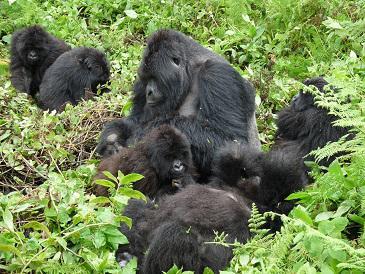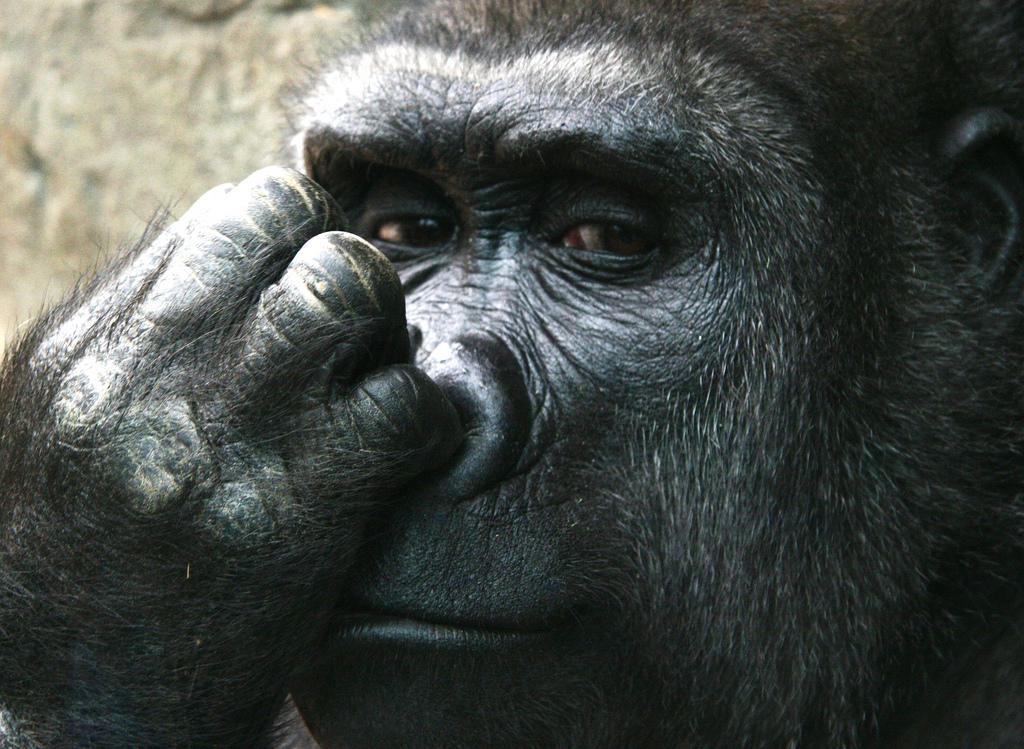The first image is the image on the left, the second image is the image on the right. Considering the images on both sides, is "An image shows one adult ape, which is touching some part of its head with one hand." valid? Answer yes or no. Yes. The first image is the image on the left, the second image is the image on the right. For the images shown, is this caption "At least one of the images contains exactly one gorilla." true? Answer yes or no. Yes. 